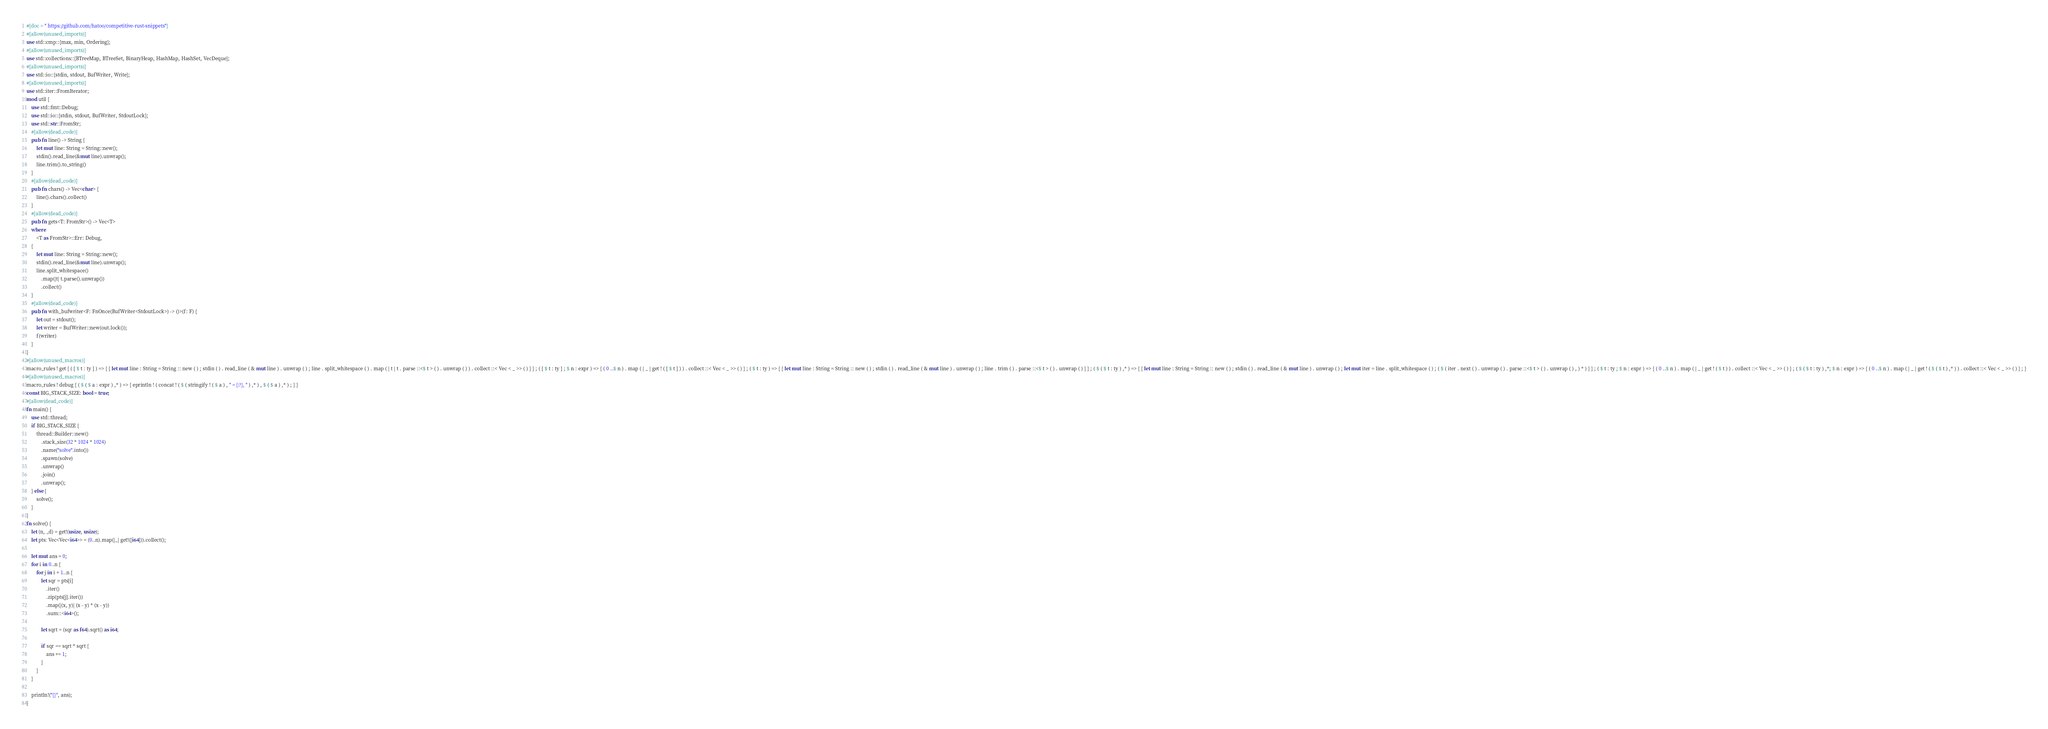<code> <loc_0><loc_0><loc_500><loc_500><_Rust_>#[doc = " https://github.com/hatoo/competitive-rust-snippets"]
#[allow(unused_imports)]
use std::cmp::{max, min, Ordering};
#[allow(unused_imports)]
use std::collections::{BTreeMap, BTreeSet, BinaryHeap, HashMap, HashSet, VecDeque};
#[allow(unused_imports)]
use std::io::{stdin, stdout, BufWriter, Write};
#[allow(unused_imports)]
use std::iter::FromIterator;
mod util {
    use std::fmt::Debug;
    use std::io::{stdin, stdout, BufWriter, StdoutLock};
    use std::str::FromStr;
    #[allow(dead_code)]
    pub fn line() -> String {
        let mut line: String = String::new();
        stdin().read_line(&mut line).unwrap();
        line.trim().to_string()
    }
    #[allow(dead_code)]
    pub fn chars() -> Vec<char> {
        line().chars().collect()
    }
    #[allow(dead_code)]
    pub fn gets<T: FromStr>() -> Vec<T>
    where
        <T as FromStr>::Err: Debug,
    {
        let mut line: String = String::new();
        stdin().read_line(&mut line).unwrap();
        line.split_whitespace()
            .map(|t| t.parse().unwrap())
            .collect()
    }
    #[allow(dead_code)]
    pub fn with_bufwriter<F: FnOnce(BufWriter<StdoutLock>) -> ()>(f: F) {
        let out = stdout();
        let writer = BufWriter::new(out.lock());
        f(writer)
    }
}
#[allow(unused_macros)]
macro_rules ! get { ( [ $ t : ty ] ) => { { let mut line : String = String :: new ( ) ; stdin ( ) . read_line ( & mut line ) . unwrap ( ) ; line . split_whitespace ( ) . map ( | t | t . parse ::<$ t > ( ) . unwrap ( ) ) . collect ::< Vec < _ >> ( ) } } ; ( [ $ t : ty ] ; $ n : expr ) => { ( 0 ..$ n ) . map ( | _ | get ! ( [ $ t ] ) ) . collect ::< Vec < _ >> ( ) } ; ( $ t : ty ) => { { let mut line : String = String :: new ( ) ; stdin ( ) . read_line ( & mut line ) . unwrap ( ) ; line . trim ( ) . parse ::<$ t > ( ) . unwrap ( ) } } ; ( $ ( $ t : ty ) ,* ) => { { let mut line : String = String :: new ( ) ; stdin ( ) . read_line ( & mut line ) . unwrap ( ) ; let mut iter = line . split_whitespace ( ) ; ( $ ( iter . next ( ) . unwrap ( ) . parse ::<$ t > ( ) . unwrap ( ) , ) * ) } } ; ( $ t : ty ; $ n : expr ) => { ( 0 ..$ n ) . map ( | _ | get ! ( $ t ) ) . collect ::< Vec < _ >> ( ) } ; ( $ ( $ t : ty ) ,*; $ n : expr ) => { ( 0 ..$ n ) . map ( | _ | get ! ( $ ( $ t ) ,* ) ) . collect ::< Vec < _ >> ( ) } ; }
#[allow(unused_macros)]
macro_rules ! debug { ( $ ( $ a : expr ) ,* ) => { eprintln ! ( concat ! ( $ ( stringify ! ( $ a ) , " = {:?}, " ) ,* ) , $ ( $ a ) ,* ) ; } }
const BIG_STACK_SIZE: bool = true;
#[allow(dead_code)]
fn main() {
    use std::thread;
    if BIG_STACK_SIZE {
        thread::Builder::new()
            .stack_size(32 * 1024 * 1024)
            .name("solve".into())
            .spawn(solve)
            .unwrap()
            .join()
            .unwrap();
    } else {
        solve();
    }
}
fn solve() {
    let (n, _d) = get!(usize, usize);
    let pts: Vec<Vec<i64>> = (0..n).map(|_| get!([i64])).collect();

    let mut ans = 0;
    for i in 0..n {
        for j in i + 1..n {
            let sqr = pts[i]
                .iter()
                .zip(pts[j].iter())
                .map(|(x, y)| (x - y) * (x - y))
                .sum::<i64>();

            let sqrt = (sqr as f64).sqrt() as i64;

            if sqr == sqrt * sqrt {
                ans += 1;
            }
        }
    }

    println!("{}", ans);
}
</code> 